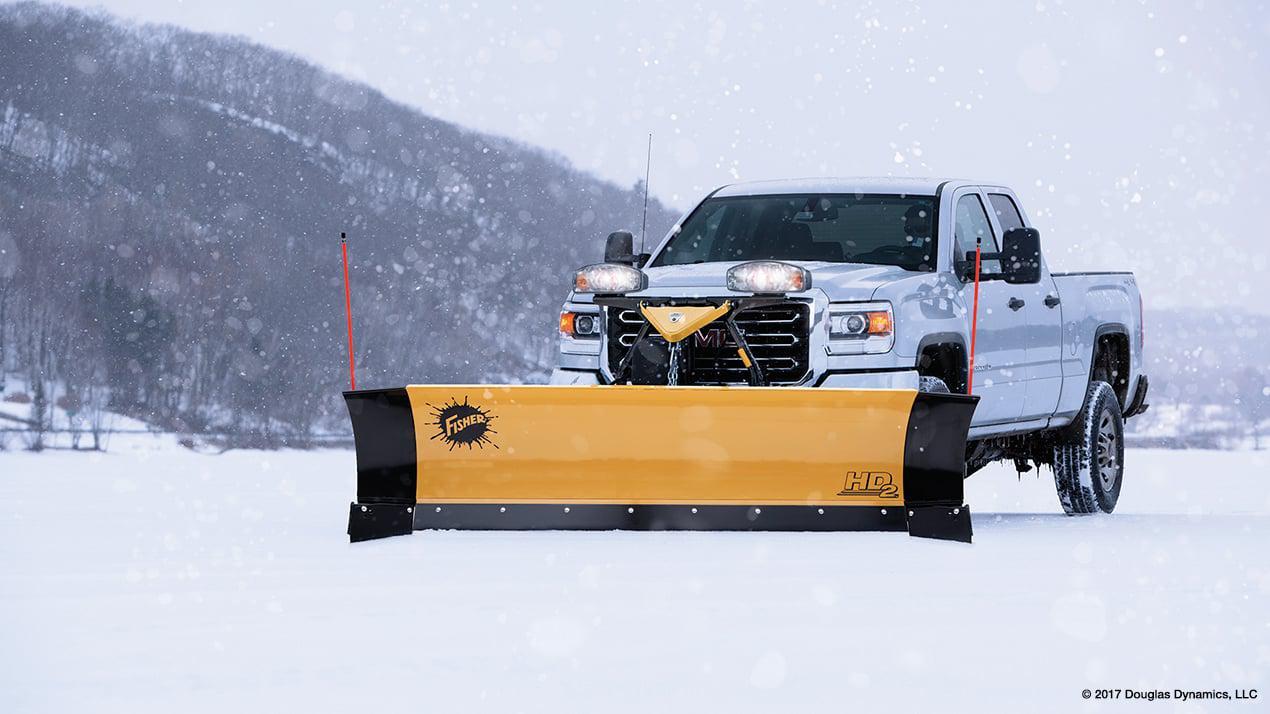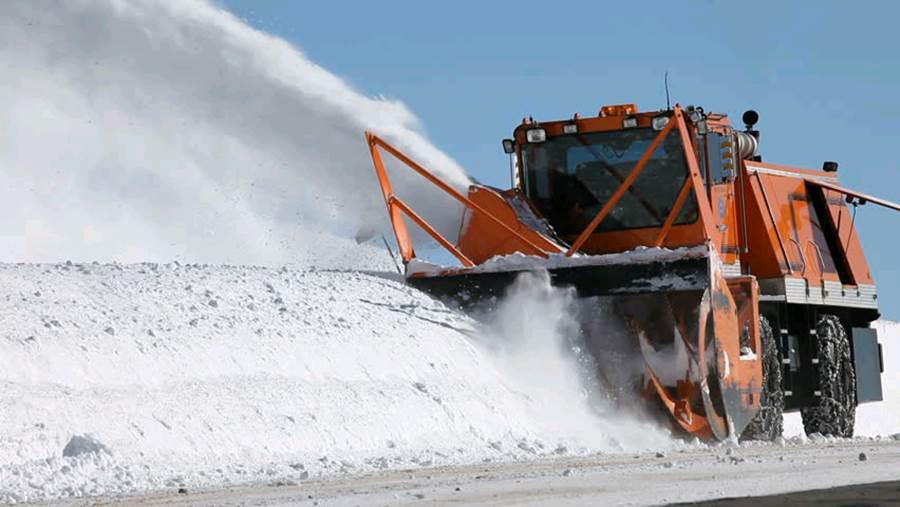The first image is the image on the left, the second image is the image on the right. Examine the images to the left and right. Is the description "The plow on the truck in the left image is yellow." accurate? Answer yes or no. Yes. 